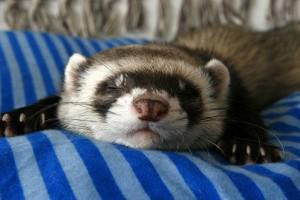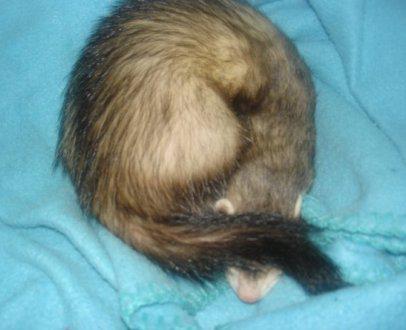The first image is the image on the left, the second image is the image on the right. Assess this claim about the two images: "The right image contains twice as many ferrets as the left image.". Correct or not? Answer yes or no. No. The first image is the image on the left, the second image is the image on the right. Examine the images to the left and right. Is the description "The right image contains exactly one ferret." accurate? Answer yes or no. Yes. 